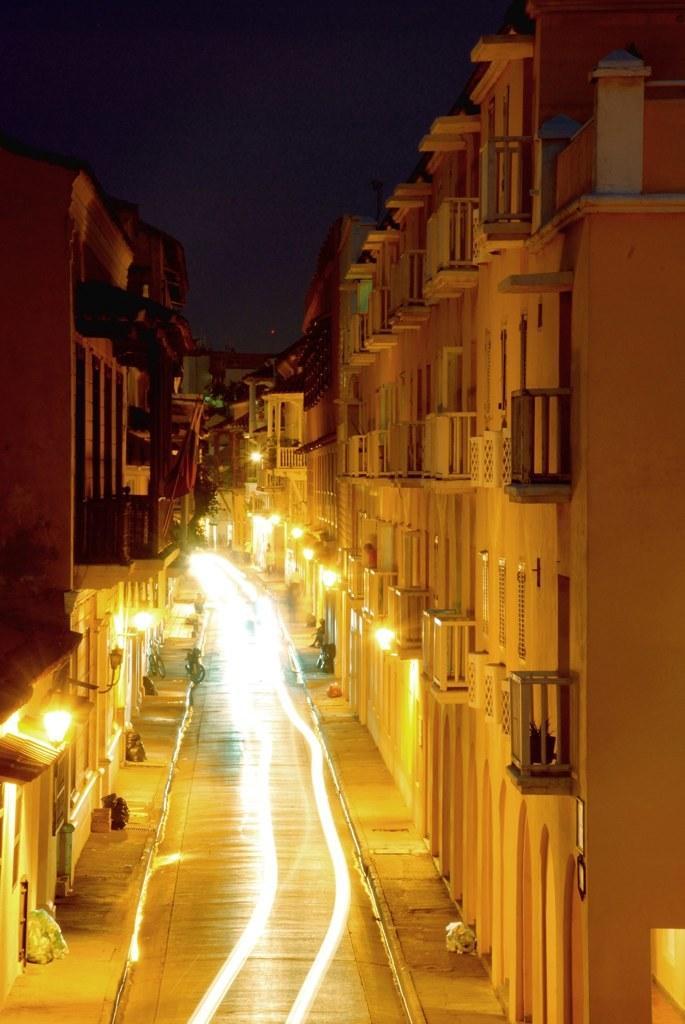Please provide a concise description of this image. In this picture we can see the sky, buildings, objects, lights and the pathway. 